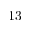<formula> <loc_0><loc_0><loc_500><loc_500>1 3</formula> 